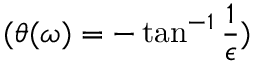<formula> <loc_0><loc_0><loc_500><loc_500>( \theta ( \omega ) = - \tan ^ { - 1 } { \frac { 1 } { \epsilon } ) }</formula> 